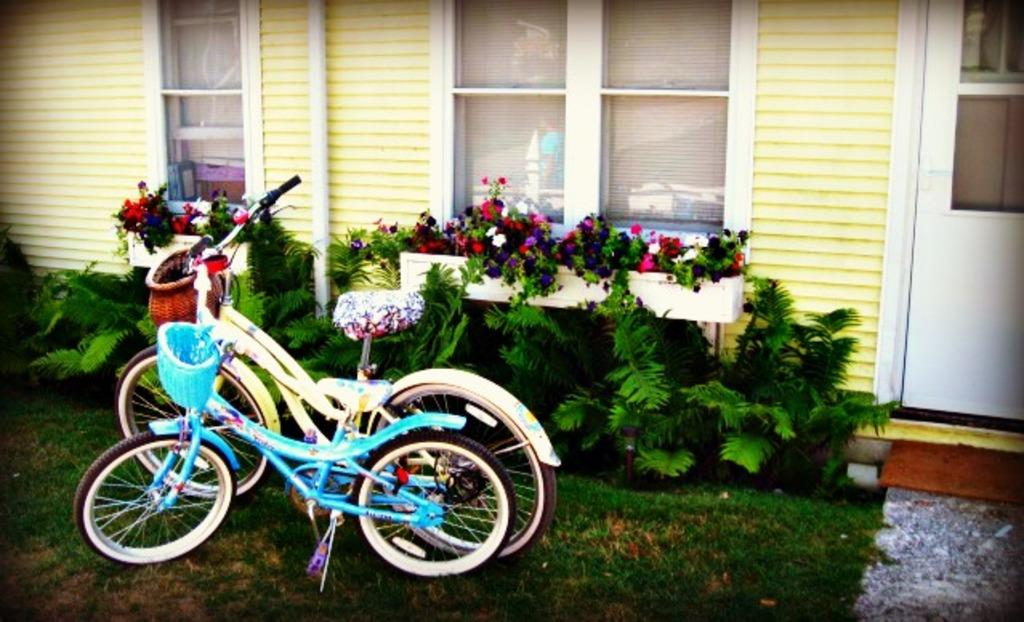What type of living organisms can be seen in the image? Plants can be seen in the image. What objects are also present in the image? Cycles are present in the image. Where are the plants and cycles located in relation to other structures? The plants and cycles are beside a wall. What architectural features can be seen in the image? There is a window at the top of the image and a door on the right side of the image. What type of things does the lawyer achieve in the image? There is no lawyer or achievement present in the image; it features plants, cycles, a wall, a window, and a door. 